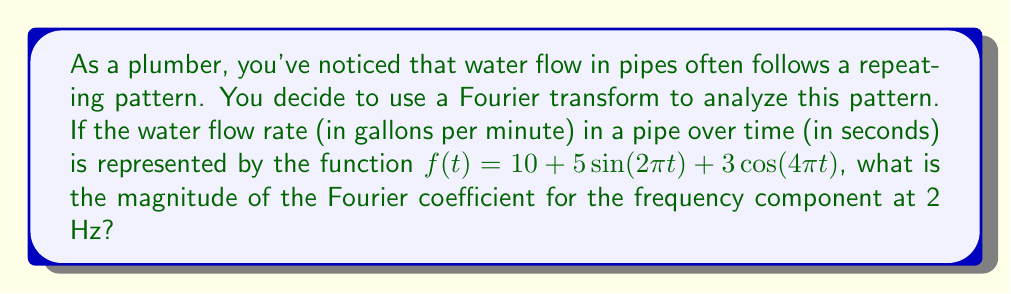Provide a solution to this math problem. Let's break this down step-by-step:

1) The Fourier transform decomposes a function into its frequency components. In this case, we already have the function expressed as a sum of sinusoids.

2) The general form of a Fourier series is:

   $$f(t) = a_0 + \sum_{n=1}^{\infty} [a_n \cos(2\pi n t) + b_n \sin(2\pi n t)]$$

3) Comparing our function to this form:

   $$f(t) = 10 + 5\sin(2\pi t) + 3\cos(4\pi t)$$

   We can identify:
   - $a_0 = 10$ (constant term)
   - $b_1 = 5$ (coefficient of $\sin(2\pi t)$)
   - $a_2 = 3$ (coefficient of $\cos(4\pi t)$)

4) The question asks for the magnitude of the Fourier coefficient at 2 Hz. This corresponds to the term with $4\pi t$ in its argument, because $2\pi(2)t = 4\pi t$.

5) The magnitude of a Fourier coefficient is given by $\sqrt{a_n^2 + b_n^2}$, where $a_n$ and $b_n$ are the cosine and sine coefficients for that frequency.

6) For the 2 Hz component, we have $a_2 = 3$ and $b_2 = 0$ (there's no sine term for this frequency).

7) Therefore, the magnitude is:

   $$\sqrt{a_2^2 + b_2^2} = \sqrt{3^2 + 0^2} = \sqrt{9} = 3$$
Answer: $3$ 